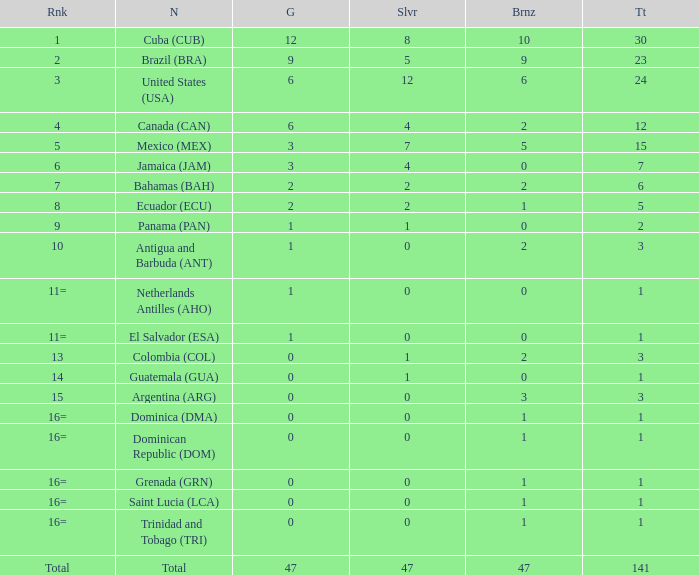How many bronzes have a Nation of jamaica (jam), and a Total smaller than 7? 0.0. 